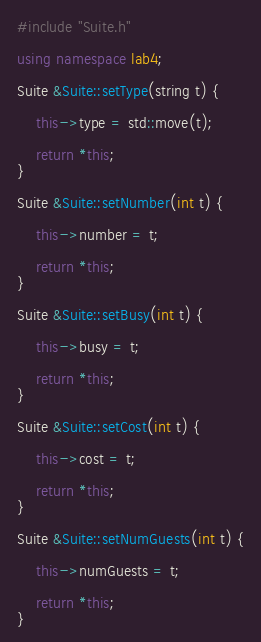<code> <loc_0><loc_0><loc_500><loc_500><_C++_>#include "Suite.h"

using namespace lab4;

Suite &Suite::setType(string t) {

    this->type = std::move(t);

    return *this;
}

Suite &Suite::setNumber(int t) {

    this->number = t;

    return *this;
}

Suite &Suite::setBusy(int t) {

    this->busy = t;

    return *this;
}

Suite &Suite::setCost(int t) {

    this->cost = t;

    return *this;
}

Suite &Suite::setNumGuests(int t) {

    this->numGuests = t;

    return *this;
}

</code> 